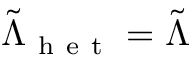Convert formula to latex. <formula><loc_0><loc_0><loc_500><loc_500>\tilde { \Lambda } _ { h e t } = \tilde { \Lambda }</formula> 